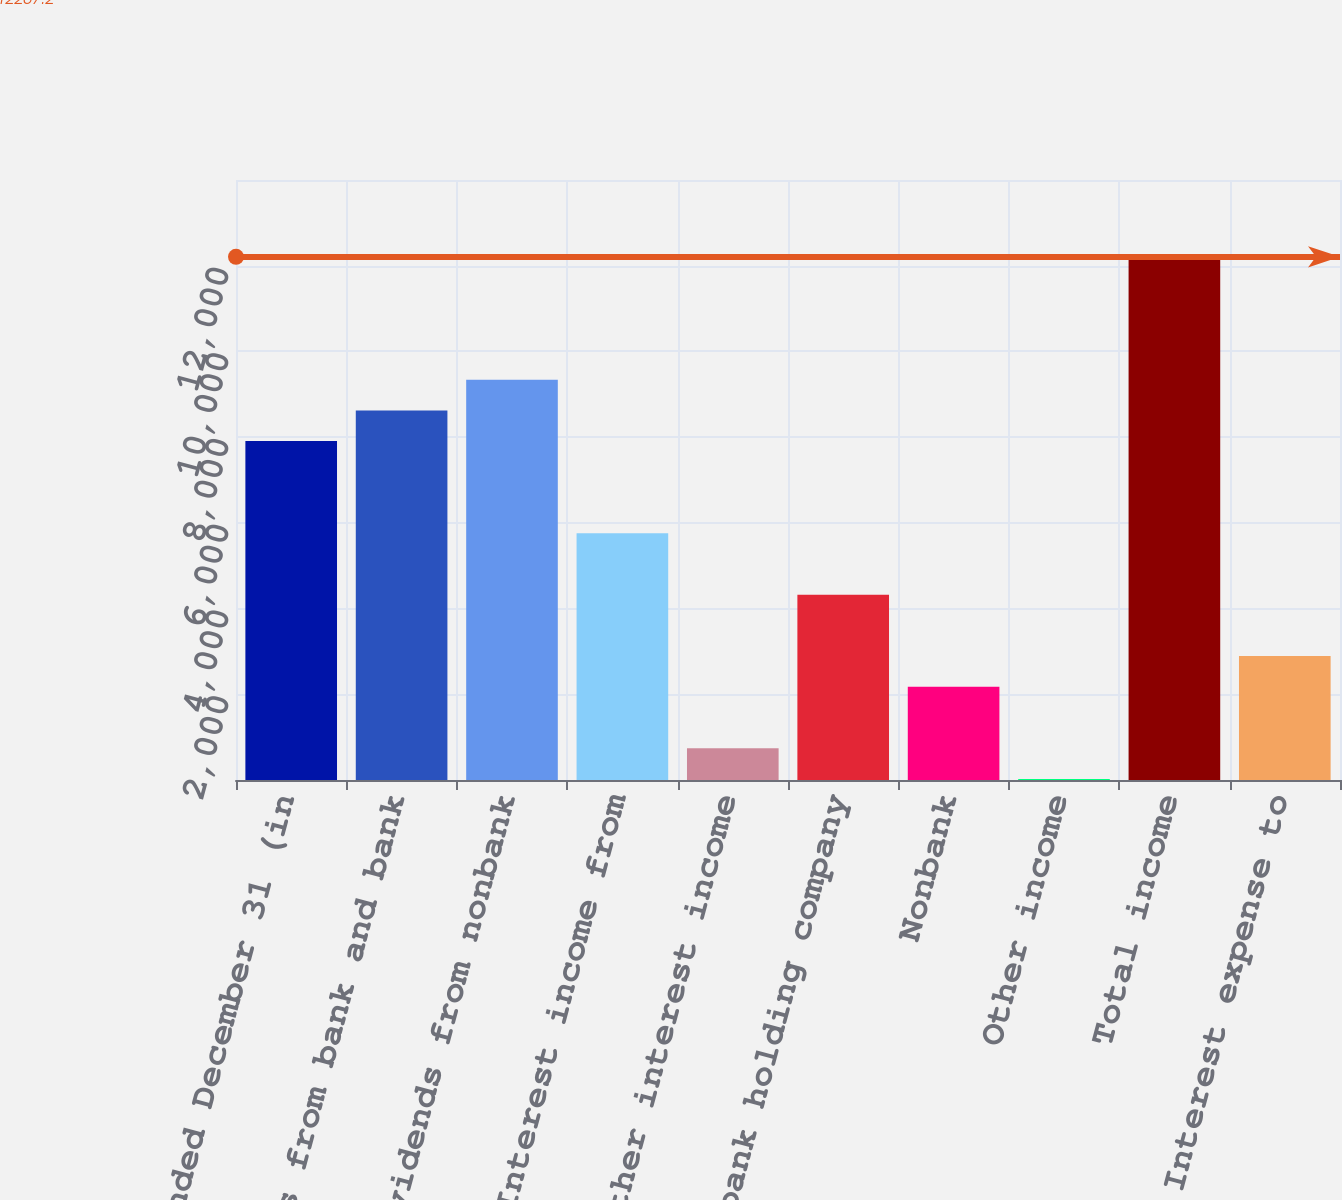<chart> <loc_0><loc_0><loc_500><loc_500><bar_chart><fcel>Year ended December 31 (in<fcel>Dividends from bank and bank<fcel>Dividends from nonbank<fcel>Interest income from<fcel>Other interest income<fcel>Bank and bank holding company<fcel>Nonbank<fcel>Other income<fcel>Total income<fcel>Interest expense to<nl><fcel>7907.6<fcel>8624.2<fcel>9340.8<fcel>5757.8<fcel>741.6<fcel>4324.6<fcel>2174.8<fcel>25<fcel>12207.2<fcel>2891.4<nl></chart> 